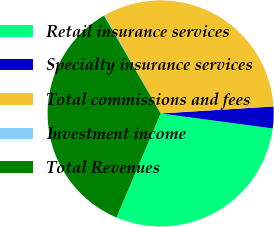<chart> <loc_0><loc_0><loc_500><loc_500><pie_chart><fcel>Retail insurance services<fcel>Specialty insurance services<fcel>Total commissions and fees<fcel>Investment income<fcel>Total Revenues<nl><fcel>29.27%<fcel>3.1%<fcel>32.26%<fcel>0.11%<fcel>35.25%<nl></chart> 